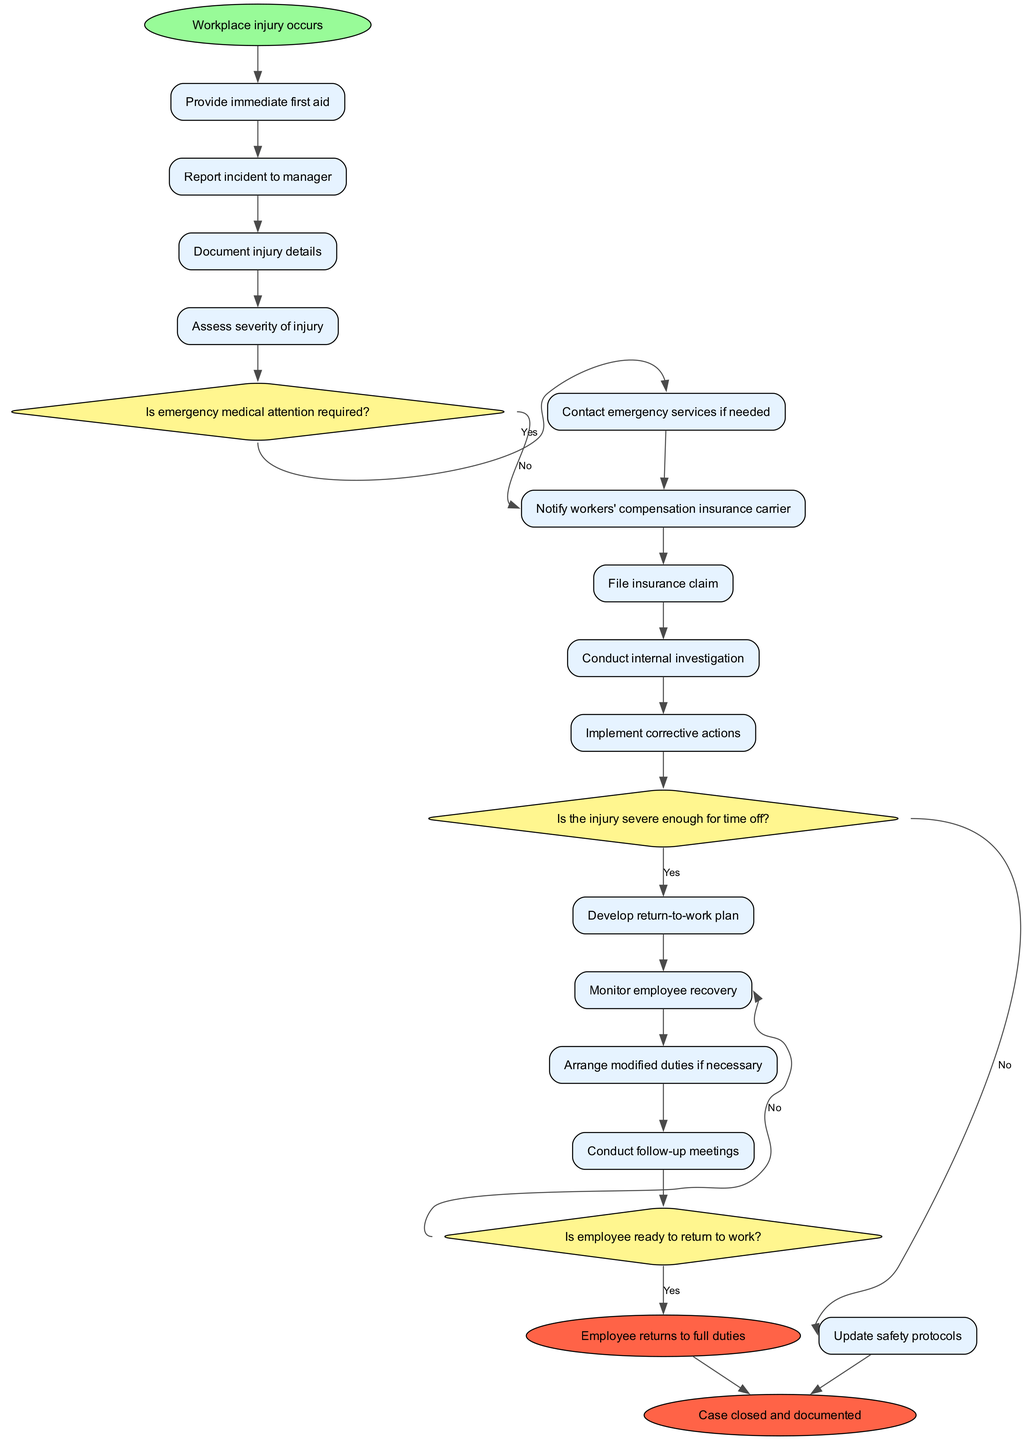What is the first activity in the diagram? The first activity is connected directly to the start node labeled "Workplace injury occurs." It's the first step in the process after the incident.
Answer: Provide immediate first aid How many activities are there in total? The diagram lists 13 activities, each representing a step that follows the occurrence of a workplace injury.
Answer: 13 What decision follows the assessment of the injury severity? After assessing the severity of the injury, the next decision made refers to whether emergency medical attention is needed, as indicated by the edge to the decision node regarding medical attention.
Answer: Is emergency medical attention required? What happens if the injury is severe enough for time off? If the injury is severe enough for time off, the diagram indicates that the process will lead to a follow-up action involving the internal investigation and documentation of the case.
Answer: Conduct internal investigation What is the last step if the employee is ready to return to work? If the employee is deemed ready to return to work, the flow of the diagram leads to the node indicating that the employee returns to full duties, signaling the end of that incident management process.
Answer: Employee returns to full duties What is the purpose of the follow-up meetings in the diagram? The follow-up meetings are included as an activity to monitor the employee's recovery process and address any issues that may affect their return to work or overall healing, ensuring proper communication and support during recovery.
Answer: Monitor employee recovery What corrective action is taken after the internal investigation? After conducting the internal investigation, the diagram specifies that corrective actions will be implemented as a response to findings gathered during the investigation, highlighting the proactive measure to prevent future incidents.
Answer: Implement corrective actions Which node does the decision about the employee's readiness to return to work lead to if they are not ready? If the employee is not ready to return to work, the decision node directs the process back to the activities, specifically the one related to monitoring employee recovery, indicating a continuous support loop until they can return.
Answer: Arrange modified duties if necessary 